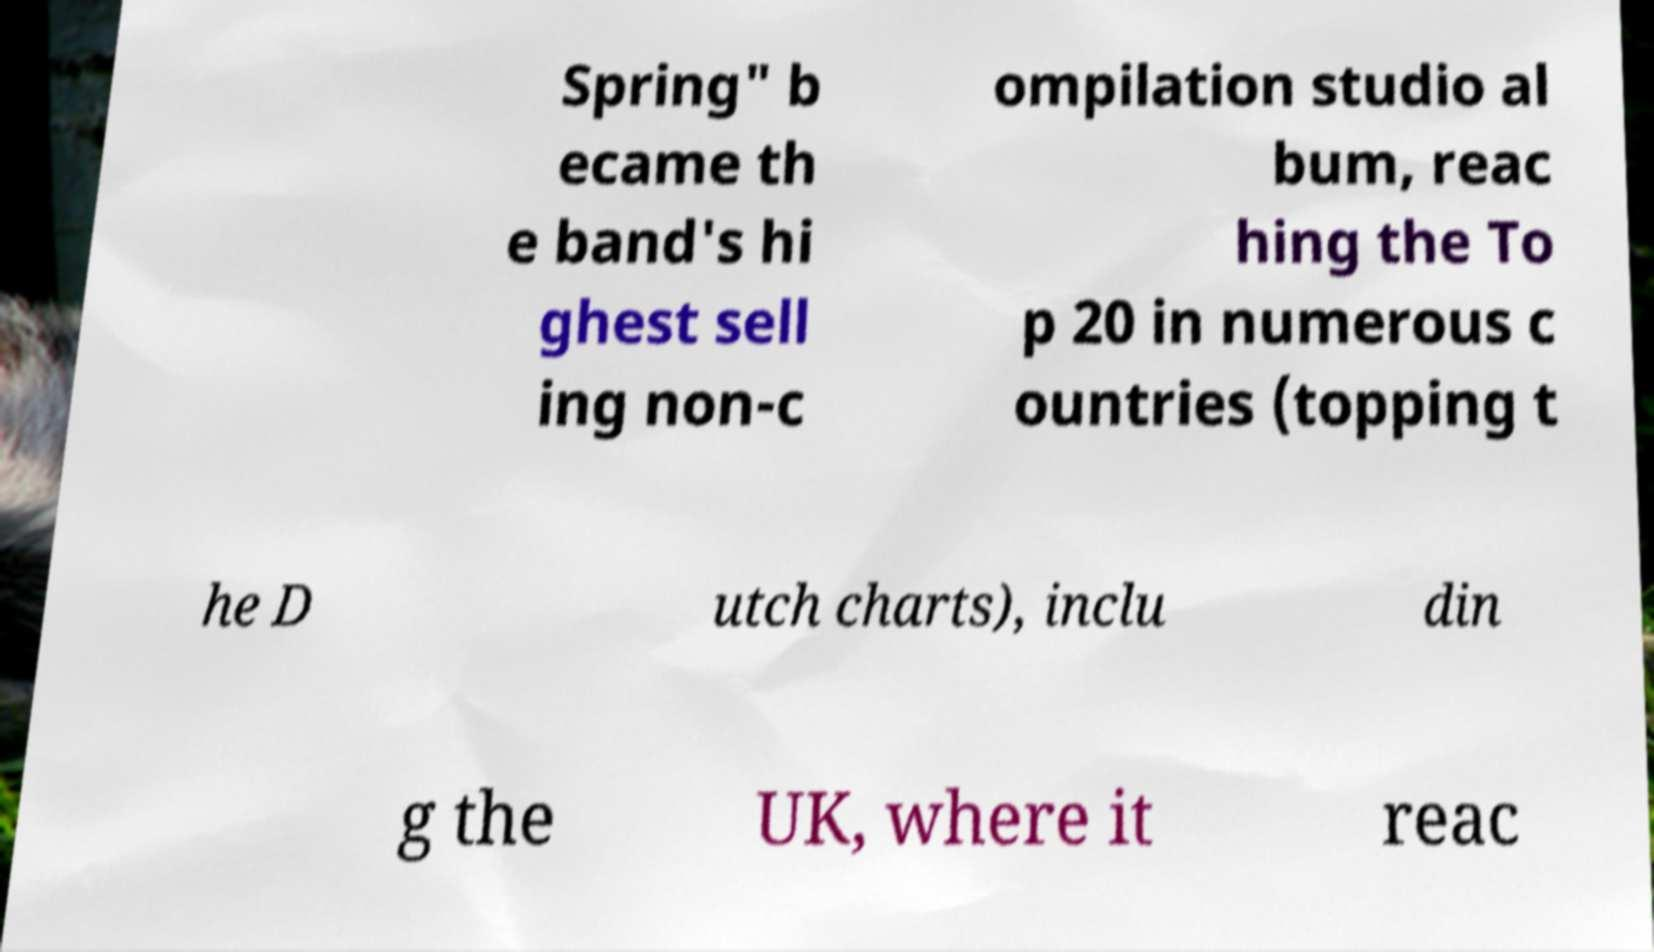There's text embedded in this image that I need extracted. Can you transcribe it verbatim? Spring" b ecame th e band's hi ghest sell ing non-c ompilation studio al bum, reac hing the To p 20 in numerous c ountries (topping t he D utch charts), inclu din g the UK, where it reac 